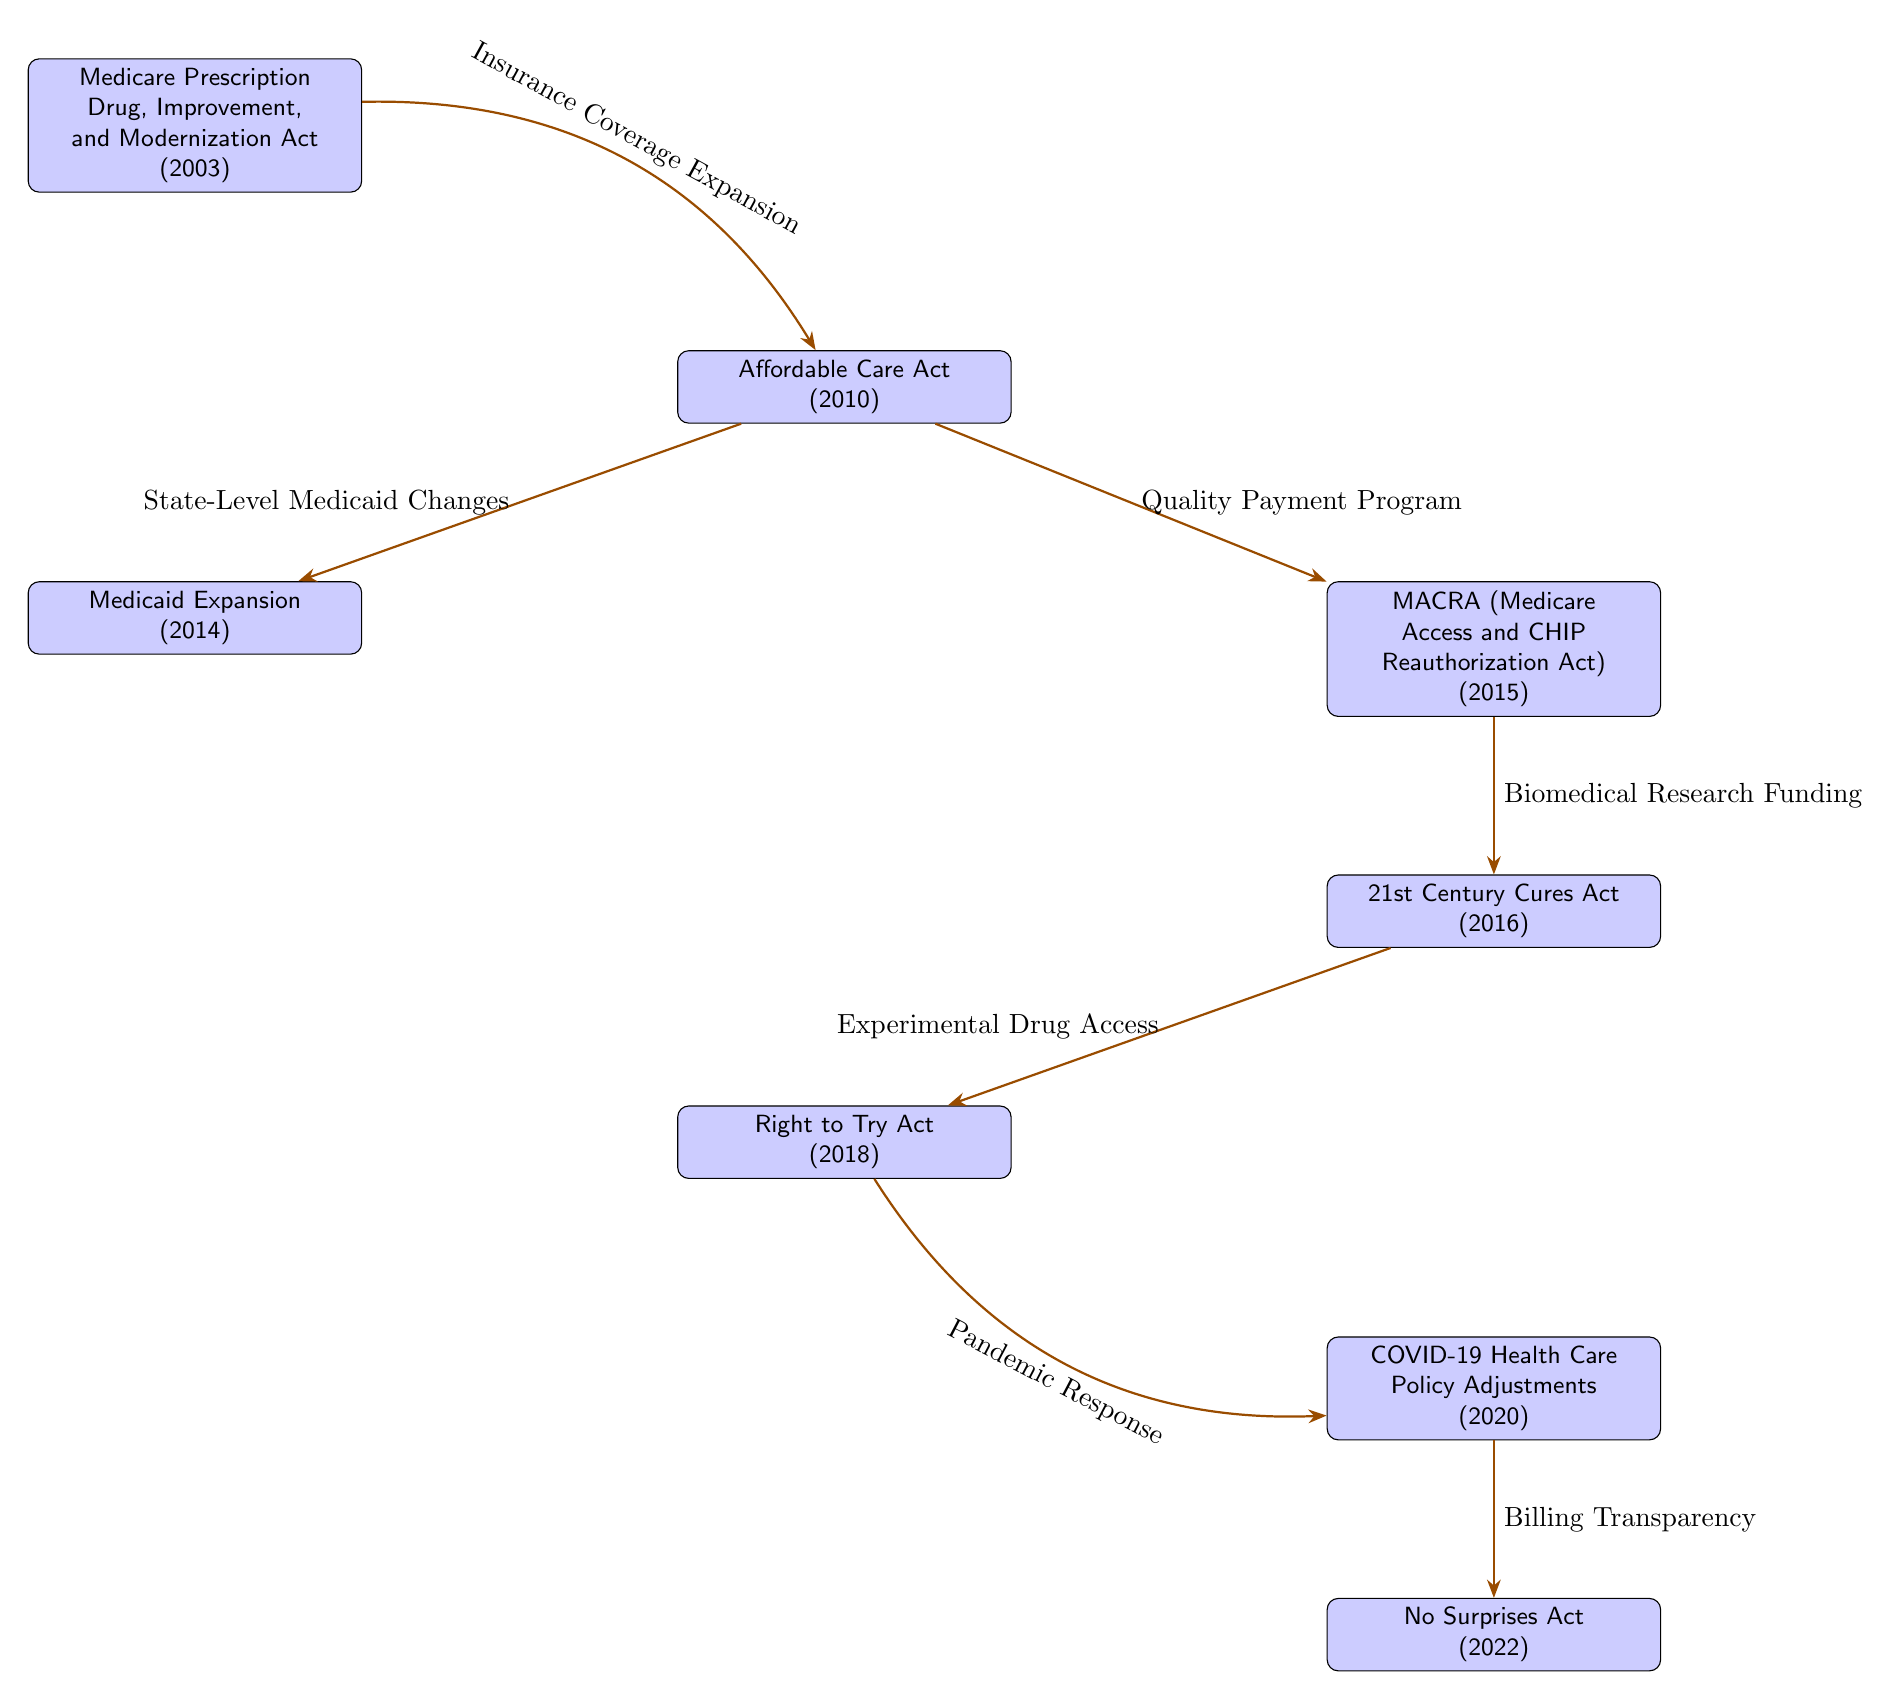What event occurred in 2003? The diagram explicitly labels the event within that year as the "Medicare Prescription Drug, Improvement, and Modernization Act."
Answer: Medicare Prescription Drug, Improvement, and Modernization Act How many major health policy reforms are depicted in the diagram? By counting the distinct events listed in the diagram, there are a total of 8 major health policy reforms presented.
Answer: 8 What is the connection between the Affordable Care Act and Medicaid Expansion? According to the diagram, the connection is indicated as "State-Level Medicaid Changes," which explains how or why Medicaid was expanded at the state level after the ACA was implemented.
Answer: State-Level Medicaid Changes Which act is related to the quality payment program? The diagram shows that the "MACRA (Medicare Access and CHIP Reauthorization Act)" is related to the quality payment program as indicated by the direct connection from the Affordable Care Act to MACRA.
Answer: MACRA (Medicare Access and CHIP Reauthorization Act) What type of access did the Right to Try Act provide? The diagram identifies that the Right to Try Act provided access related to "Experimental Drug Access," showcasing the focus of this reform on alternative treatment pathways for patients.
Answer: Experimental Drug Access What was the significant event in 2020? The diagram marks "COVID-19 Health Care Policy Adjustments" as the significant health policy reform that took place in 2020, reflecting the response to the pandemic.
Answer: COVID-19 Health Care Policy Adjustments What is the focus of the No Surprises Act? The diagram indicates that the focus of the No Surprises Act is on "Billing Transparency," which aims to address unexpected medical bills that patients frequently receive.
Answer: Billing Transparency What act connects pandemic response to 2020? The diagram connects "Right to Try Act," as it highlights "Pandemic Response" causing adjustments in health care policy in 2020, reflecting how previous acts facilitated responses to the COVID crisis.
Answer: COVID-19 Health Care Policy Adjustments 